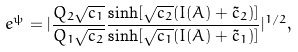<formula> <loc_0><loc_0><loc_500><loc_500>e ^ { \psi } = | \frac { Q _ { 2 } \sqrt { c _ { 1 } } } { Q _ { 1 } \sqrt { c _ { 2 } } } \frac { \sinh [ \sqrt { c _ { 2 } } ( I ( A ) + \tilde { c } _ { 2 } ) ] } { \sinh [ \sqrt { c _ { 1 } } ( I ( A ) + \tilde { c } _ { 1 } ) ] } | ^ { 1 / 2 } ,</formula> 